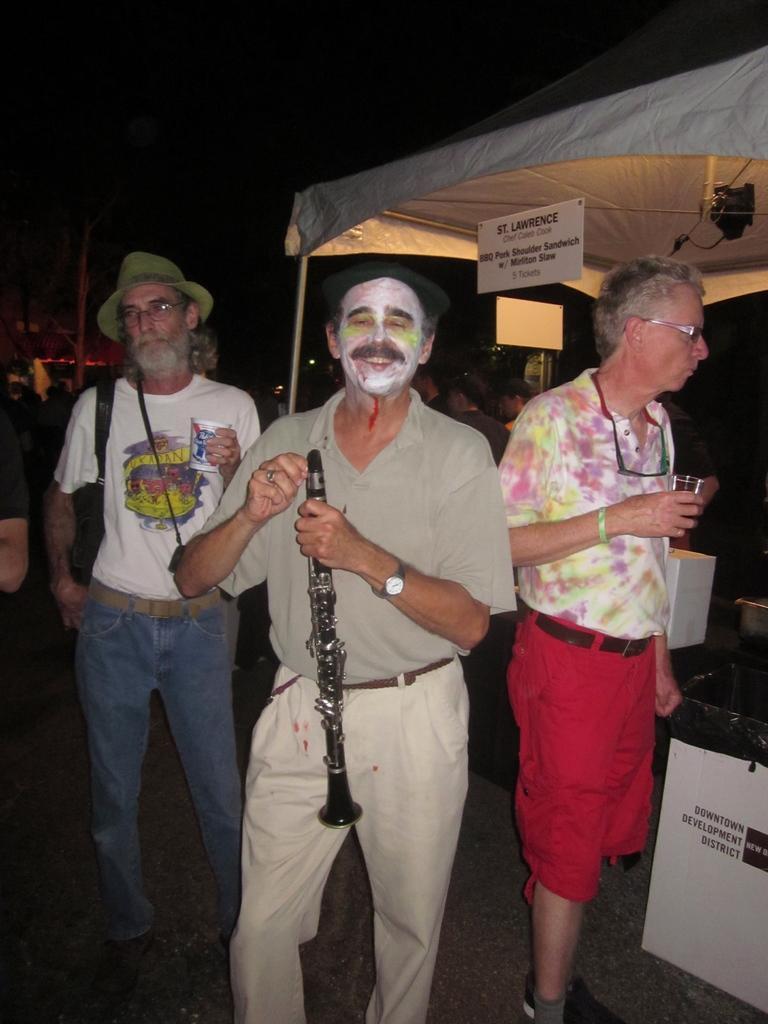Describe this image in one or two sentences. In this picture we can see three men standing on the ground were two are holding glasses with their hands and a man holding a clarinet with his hand and smiling and at the back of them we can see a tent, name boards, some objects and some people and in the background it is dark. 